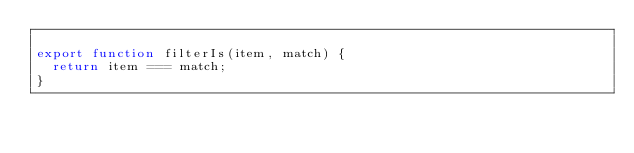Convert code to text. <code><loc_0><loc_0><loc_500><loc_500><_JavaScript_>
export function filterIs(item, match) {
  return item === match;
}
</code> 